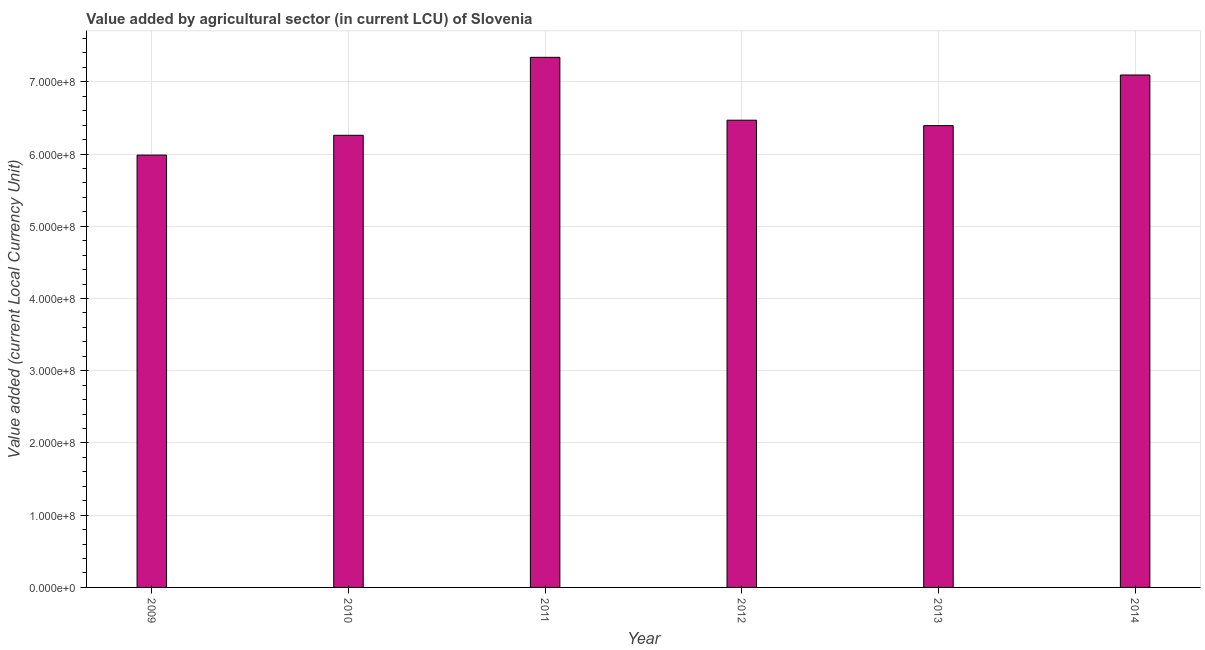What is the title of the graph?
Keep it short and to the point. Value added by agricultural sector (in current LCU) of Slovenia. What is the label or title of the Y-axis?
Offer a terse response. Value added (current Local Currency Unit). What is the value added by agriculture sector in 2010?
Give a very brief answer. 6.26e+08. Across all years, what is the maximum value added by agriculture sector?
Offer a terse response. 7.34e+08. Across all years, what is the minimum value added by agriculture sector?
Offer a very short reply. 5.99e+08. In which year was the value added by agriculture sector maximum?
Your response must be concise. 2011. What is the sum of the value added by agriculture sector?
Ensure brevity in your answer.  3.95e+09. What is the difference between the value added by agriculture sector in 2009 and 2013?
Your answer should be compact. -4.08e+07. What is the average value added by agriculture sector per year?
Keep it short and to the point. 6.59e+08. What is the median value added by agriculture sector?
Make the answer very short. 6.43e+08. In how many years, is the value added by agriculture sector greater than 740000000 LCU?
Keep it short and to the point. 0. What is the ratio of the value added by agriculture sector in 2010 to that in 2012?
Make the answer very short. 0.97. Is the value added by agriculture sector in 2010 less than that in 2013?
Give a very brief answer. Yes. Is the difference between the value added by agriculture sector in 2010 and 2012 greater than the difference between any two years?
Offer a very short reply. No. What is the difference between the highest and the second highest value added by agriculture sector?
Offer a very short reply. 2.45e+07. Is the sum of the value added by agriculture sector in 2011 and 2013 greater than the maximum value added by agriculture sector across all years?
Ensure brevity in your answer.  Yes. What is the difference between the highest and the lowest value added by agriculture sector?
Offer a terse response. 1.35e+08. In how many years, is the value added by agriculture sector greater than the average value added by agriculture sector taken over all years?
Ensure brevity in your answer.  2. How many bars are there?
Provide a short and direct response. 6. Are all the bars in the graph horizontal?
Provide a succinct answer. No. What is the difference between two consecutive major ticks on the Y-axis?
Provide a short and direct response. 1.00e+08. Are the values on the major ticks of Y-axis written in scientific E-notation?
Make the answer very short. Yes. What is the Value added (current Local Currency Unit) of 2009?
Make the answer very short. 5.99e+08. What is the Value added (current Local Currency Unit) of 2010?
Provide a short and direct response. 6.26e+08. What is the Value added (current Local Currency Unit) in 2011?
Your response must be concise. 7.34e+08. What is the Value added (current Local Currency Unit) of 2012?
Your answer should be compact. 6.47e+08. What is the Value added (current Local Currency Unit) in 2013?
Give a very brief answer. 6.39e+08. What is the Value added (current Local Currency Unit) of 2014?
Your answer should be very brief. 7.09e+08. What is the difference between the Value added (current Local Currency Unit) in 2009 and 2010?
Give a very brief answer. -2.74e+07. What is the difference between the Value added (current Local Currency Unit) in 2009 and 2011?
Ensure brevity in your answer.  -1.35e+08. What is the difference between the Value added (current Local Currency Unit) in 2009 and 2012?
Your response must be concise. -4.83e+07. What is the difference between the Value added (current Local Currency Unit) in 2009 and 2013?
Offer a very short reply. -4.08e+07. What is the difference between the Value added (current Local Currency Unit) in 2009 and 2014?
Make the answer very short. -1.11e+08. What is the difference between the Value added (current Local Currency Unit) in 2010 and 2011?
Offer a very short reply. -1.08e+08. What is the difference between the Value added (current Local Currency Unit) in 2010 and 2012?
Give a very brief answer. -2.09e+07. What is the difference between the Value added (current Local Currency Unit) in 2010 and 2013?
Your answer should be compact. -1.34e+07. What is the difference between the Value added (current Local Currency Unit) in 2010 and 2014?
Provide a succinct answer. -8.35e+07. What is the difference between the Value added (current Local Currency Unit) in 2011 and 2012?
Your answer should be compact. 8.70e+07. What is the difference between the Value added (current Local Currency Unit) in 2011 and 2013?
Offer a very short reply. 9.46e+07. What is the difference between the Value added (current Local Currency Unit) in 2011 and 2014?
Your answer should be compact. 2.45e+07. What is the difference between the Value added (current Local Currency Unit) in 2012 and 2013?
Offer a terse response. 7.53e+06. What is the difference between the Value added (current Local Currency Unit) in 2012 and 2014?
Your answer should be compact. -6.26e+07. What is the difference between the Value added (current Local Currency Unit) in 2013 and 2014?
Keep it short and to the point. -7.01e+07. What is the ratio of the Value added (current Local Currency Unit) in 2009 to that in 2010?
Your answer should be compact. 0.96. What is the ratio of the Value added (current Local Currency Unit) in 2009 to that in 2011?
Make the answer very short. 0.82. What is the ratio of the Value added (current Local Currency Unit) in 2009 to that in 2012?
Provide a succinct answer. 0.93. What is the ratio of the Value added (current Local Currency Unit) in 2009 to that in 2013?
Keep it short and to the point. 0.94. What is the ratio of the Value added (current Local Currency Unit) in 2009 to that in 2014?
Offer a very short reply. 0.84. What is the ratio of the Value added (current Local Currency Unit) in 2010 to that in 2011?
Give a very brief answer. 0.85. What is the ratio of the Value added (current Local Currency Unit) in 2010 to that in 2012?
Your response must be concise. 0.97. What is the ratio of the Value added (current Local Currency Unit) in 2010 to that in 2013?
Your answer should be compact. 0.98. What is the ratio of the Value added (current Local Currency Unit) in 2010 to that in 2014?
Your response must be concise. 0.88. What is the ratio of the Value added (current Local Currency Unit) in 2011 to that in 2012?
Provide a short and direct response. 1.14. What is the ratio of the Value added (current Local Currency Unit) in 2011 to that in 2013?
Your answer should be very brief. 1.15. What is the ratio of the Value added (current Local Currency Unit) in 2011 to that in 2014?
Your answer should be very brief. 1.03. What is the ratio of the Value added (current Local Currency Unit) in 2012 to that in 2013?
Your answer should be very brief. 1.01. What is the ratio of the Value added (current Local Currency Unit) in 2012 to that in 2014?
Provide a short and direct response. 0.91. What is the ratio of the Value added (current Local Currency Unit) in 2013 to that in 2014?
Offer a very short reply. 0.9. 